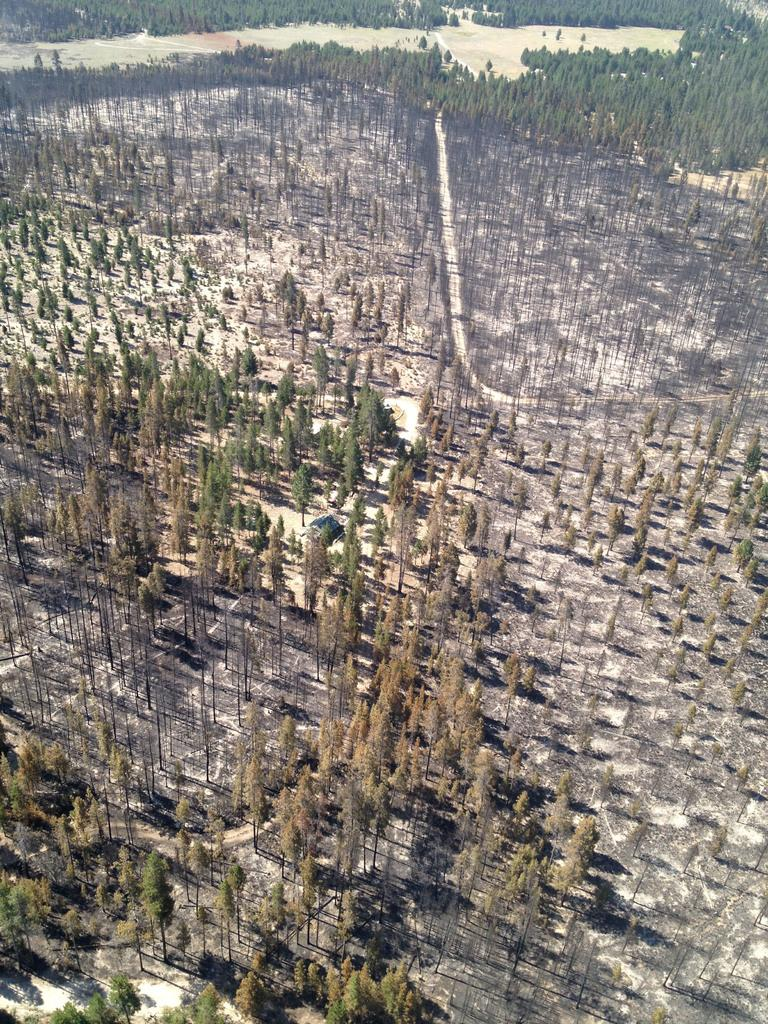What type of environment is shown in the image? The image depicts a forest. What are the main features of the forest? There are trees in the image. What type of terrain is visible in the image? There is dry land visible in the image. Where is the nail placed on the stage in the image? There is no nail, stage, or throne present in the image; it depicts a forest with trees and dry land. 